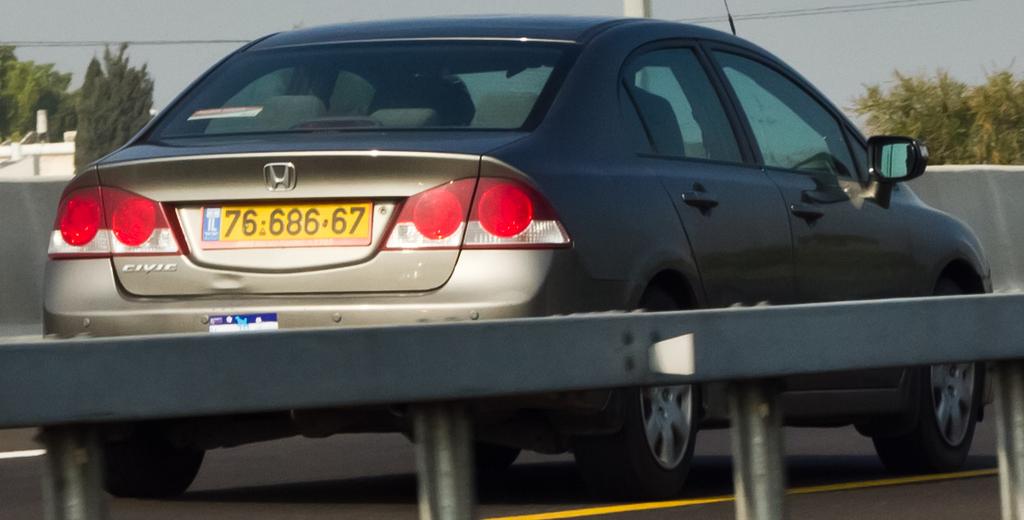What is the license plate number?
Keep it short and to the point. 76 686 67. What model is the car right below the tailight?
Offer a very short reply. Civic. 